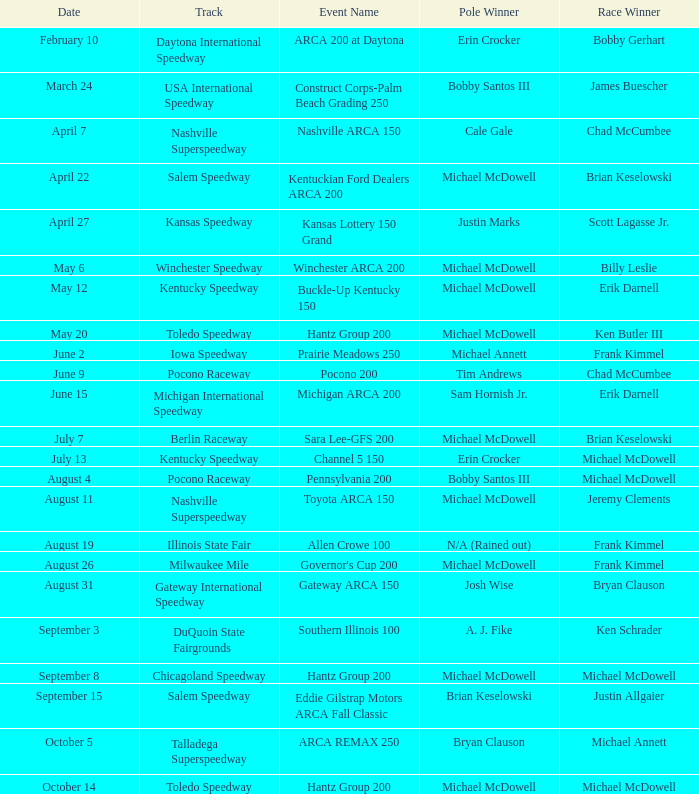Provide the occasion name involving michael mcdowell and billy leslie. Winchester ARCA 200. 